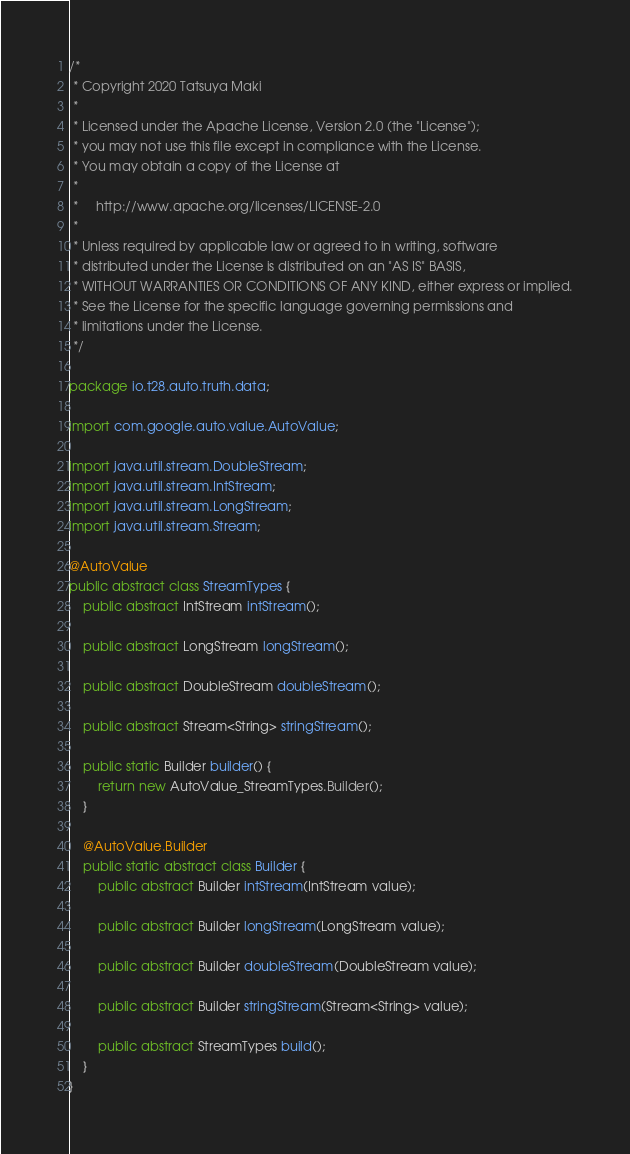<code> <loc_0><loc_0><loc_500><loc_500><_Java_>/*
 * Copyright 2020 Tatsuya Maki
 *
 * Licensed under the Apache License, Version 2.0 (the "License");
 * you may not use this file except in compliance with the License.
 * You may obtain a copy of the License at
 *
 *     http://www.apache.org/licenses/LICENSE-2.0
 *
 * Unless required by applicable law or agreed to in writing, software
 * distributed under the License is distributed on an "AS IS" BASIS,
 * WITHOUT WARRANTIES OR CONDITIONS OF ANY KIND, either express or implied.
 * See the License for the specific language governing permissions and
 * limitations under the License.
 */

package io.t28.auto.truth.data;

import com.google.auto.value.AutoValue;

import java.util.stream.DoubleStream;
import java.util.stream.IntStream;
import java.util.stream.LongStream;
import java.util.stream.Stream;

@AutoValue
public abstract class StreamTypes {
    public abstract IntStream intStream();

    public abstract LongStream longStream();

    public abstract DoubleStream doubleStream();

    public abstract Stream<String> stringStream();

    public static Builder builder() {
        return new AutoValue_StreamTypes.Builder();
    }

    @AutoValue.Builder
    public static abstract class Builder {
        public abstract Builder intStream(IntStream value);

        public abstract Builder longStream(LongStream value);

        public abstract Builder doubleStream(DoubleStream value);

        public abstract Builder stringStream(Stream<String> value);

        public abstract StreamTypes build();
    }
}
</code> 